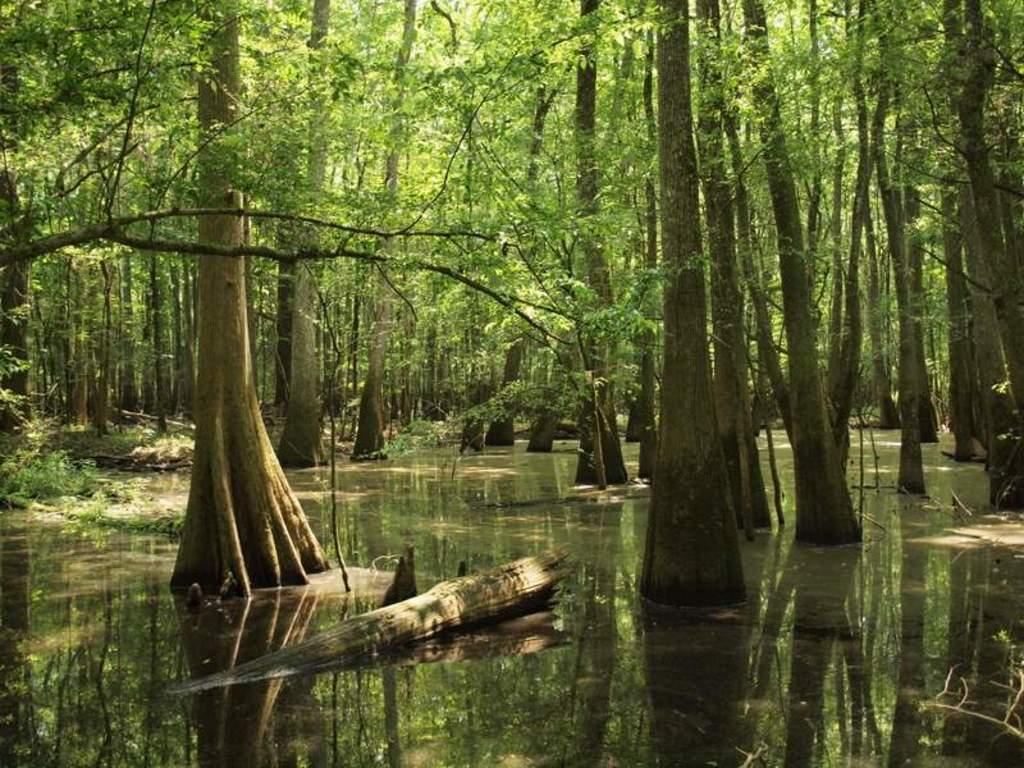What is visible in the image? There is water and trees visible in the image. Can you describe the water in the image? The water is visible, but its specific characteristics are not mentioned in the facts. What type of vegetation is present in the image? Trees are present in the image. What type of club is being used to catch fish in the image? There is no club or fishing activity depicted in the image; it only features water and trees. What kind of bait is being used to attract fish in the image? There is no fishing activity or bait present in the image. 